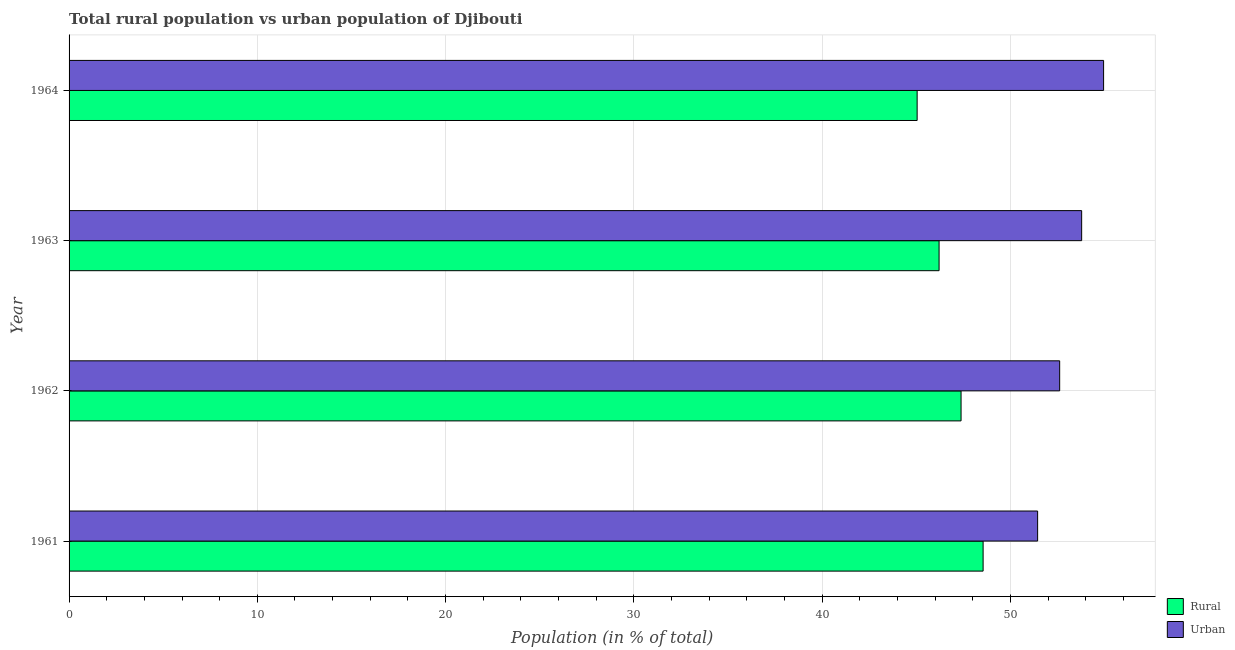How many different coloured bars are there?
Give a very brief answer. 2. Are the number of bars per tick equal to the number of legend labels?
Make the answer very short. Yes. How many bars are there on the 2nd tick from the bottom?
Your answer should be compact. 2. What is the label of the 1st group of bars from the top?
Give a very brief answer. 1964. In how many cases, is the number of bars for a given year not equal to the number of legend labels?
Your answer should be very brief. 0. What is the urban population in 1962?
Provide a short and direct response. 52.62. Across all years, what is the maximum urban population?
Offer a very short reply. 54.95. Across all years, what is the minimum urban population?
Provide a short and direct response. 51.45. In which year was the urban population maximum?
Your answer should be compact. 1964. In which year was the rural population minimum?
Offer a very short reply. 1964. What is the total rural population in the graph?
Keep it short and to the point. 187.19. What is the difference between the urban population in 1962 and that in 1964?
Your answer should be compact. -2.33. What is the difference between the urban population in 1964 and the rural population in 1963?
Keep it short and to the point. 8.74. What is the average rural population per year?
Offer a terse response. 46.8. In the year 1963, what is the difference between the rural population and urban population?
Offer a terse response. -7.57. What is the ratio of the urban population in 1962 to that in 1964?
Provide a short and direct response. 0.96. Is the rural population in 1961 less than that in 1964?
Your answer should be very brief. No. Is the difference between the rural population in 1961 and 1962 greater than the difference between the urban population in 1961 and 1962?
Your answer should be compact. Yes. What is the difference between the highest and the second highest urban population?
Give a very brief answer. 1.17. What is the difference between the highest and the lowest rural population?
Ensure brevity in your answer.  3.5. In how many years, is the urban population greater than the average urban population taken over all years?
Your answer should be very brief. 2. What does the 2nd bar from the top in 1961 represents?
Keep it short and to the point. Rural. What does the 1st bar from the bottom in 1962 represents?
Make the answer very short. Rural. Are all the bars in the graph horizontal?
Provide a short and direct response. Yes. Are the values on the major ticks of X-axis written in scientific E-notation?
Ensure brevity in your answer.  No. Does the graph contain grids?
Provide a succinct answer. Yes. Where does the legend appear in the graph?
Offer a very short reply. Bottom right. How many legend labels are there?
Offer a terse response. 2. How are the legend labels stacked?
Ensure brevity in your answer.  Vertical. What is the title of the graph?
Give a very brief answer. Total rural population vs urban population of Djibouti. Does "Official aid received" appear as one of the legend labels in the graph?
Keep it short and to the point. No. What is the label or title of the X-axis?
Offer a terse response. Population (in % of total). What is the label or title of the Y-axis?
Ensure brevity in your answer.  Year. What is the Population (in % of total) of Rural in 1961?
Provide a short and direct response. 48.55. What is the Population (in % of total) of Urban in 1961?
Your response must be concise. 51.45. What is the Population (in % of total) in Rural in 1962?
Provide a short and direct response. 47.38. What is the Population (in % of total) in Urban in 1962?
Offer a terse response. 52.62. What is the Population (in % of total) of Rural in 1963?
Provide a succinct answer. 46.21. What is the Population (in % of total) of Urban in 1963?
Offer a very short reply. 53.79. What is the Population (in % of total) in Rural in 1964?
Your answer should be very brief. 45.05. What is the Population (in % of total) in Urban in 1964?
Your response must be concise. 54.95. Across all years, what is the maximum Population (in % of total) in Rural?
Provide a short and direct response. 48.55. Across all years, what is the maximum Population (in % of total) of Urban?
Make the answer very short. 54.95. Across all years, what is the minimum Population (in % of total) of Rural?
Make the answer very short. 45.05. Across all years, what is the minimum Population (in % of total) of Urban?
Your response must be concise. 51.45. What is the total Population (in % of total) of Rural in the graph?
Make the answer very short. 187.19. What is the total Population (in % of total) of Urban in the graph?
Offer a terse response. 212.81. What is the difference between the Population (in % of total) of Rural in 1961 and that in 1962?
Provide a short and direct response. 1.17. What is the difference between the Population (in % of total) in Urban in 1961 and that in 1962?
Your answer should be very brief. -1.17. What is the difference between the Population (in % of total) of Rural in 1961 and that in 1963?
Offer a very short reply. 2.34. What is the difference between the Population (in % of total) in Urban in 1961 and that in 1963?
Make the answer very short. -2.34. What is the difference between the Population (in % of total) in Rural in 1961 and that in 1964?
Provide a succinct answer. 3.5. What is the difference between the Population (in % of total) in Urban in 1961 and that in 1964?
Keep it short and to the point. -3.5. What is the difference between the Population (in % of total) of Rural in 1962 and that in 1963?
Provide a short and direct response. 1.17. What is the difference between the Population (in % of total) of Urban in 1962 and that in 1963?
Offer a very short reply. -1.17. What is the difference between the Population (in % of total) in Rural in 1962 and that in 1964?
Give a very brief answer. 2.33. What is the difference between the Population (in % of total) of Urban in 1962 and that in 1964?
Provide a succinct answer. -2.33. What is the difference between the Population (in % of total) in Rural in 1963 and that in 1964?
Provide a succinct answer. 1.17. What is the difference between the Population (in % of total) in Urban in 1963 and that in 1964?
Ensure brevity in your answer.  -1.17. What is the difference between the Population (in % of total) in Rural in 1961 and the Population (in % of total) in Urban in 1962?
Make the answer very short. -4.07. What is the difference between the Population (in % of total) in Rural in 1961 and the Population (in % of total) in Urban in 1963?
Provide a succinct answer. -5.24. What is the difference between the Population (in % of total) of Rural in 1962 and the Population (in % of total) of Urban in 1963?
Give a very brief answer. -6.41. What is the difference between the Population (in % of total) in Rural in 1962 and the Population (in % of total) in Urban in 1964?
Your answer should be very brief. -7.57. What is the difference between the Population (in % of total) in Rural in 1963 and the Population (in % of total) in Urban in 1964?
Offer a terse response. -8.74. What is the average Population (in % of total) in Rural per year?
Your answer should be very brief. 46.8. What is the average Population (in % of total) of Urban per year?
Offer a very short reply. 53.2. In the year 1961, what is the difference between the Population (in % of total) of Rural and Population (in % of total) of Urban?
Provide a short and direct response. -2.9. In the year 1962, what is the difference between the Population (in % of total) of Rural and Population (in % of total) of Urban?
Ensure brevity in your answer.  -5.24. In the year 1963, what is the difference between the Population (in % of total) of Rural and Population (in % of total) of Urban?
Offer a terse response. -7.57. In the year 1964, what is the difference between the Population (in % of total) in Rural and Population (in % of total) in Urban?
Give a very brief answer. -9.9. What is the ratio of the Population (in % of total) in Rural in 1961 to that in 1962?
Keep it short and to the point. 1.02. What is the ratio of the Population (in % of total) of Urban in 1961 to that in 1962?
Offer a terse response. 0.98. What is the ratio of the Population (in % of total) of Rural in 1961 to that in 1963?
Your response must be concise. 1.05. What is the ratio of the Population (in % of total) of Urban in 1961 to that in 1963?
Provide a succinct answer. 0.96. What is the ratio of the Population (in % of total) in Rural in 1961 to that in 1964?
Your answer should be very brief. 1.08. What is the ratio of the Population (in % of total) of Urban in 1961 to that in 1964?
Ensure brevity in your answer.  0.94. What is the ratio of the Population (in % of total) in Rural in 1962 to that in 1963?
Give a very brief answer. 1.03. What is the ratio of the Population (in % of total) in Urban in 1962 to that in 1963?
Provide a succinct answer. 0.98. What is the ratio of the Population (in % of total) in Rural in 1962 to that in 1964?
Keep it short and to the point. 1.05. What is the ratio of the Population (in % of total) of Urban in 1962 to that in 1964?
Ensure brevity in your answer.  0.96. What is the ratio of the Population (in % of total) of Rural in 1963 to that in 1964?
Your answer should be compact. 1.03. What is the ratio of the Population (in % of total) of Urban in 1963 to that in 1964?
Your answer should be very brief. 0.98. What is the difference between the highest and the second highest Population (in % of total) in Rural?
Keep it short and to the point. 1.17. What is the difference between the highest and the second highest Population (in % of total) of Urban?
Provide a short and direct response. 1.17. What is the difference between the highest and the lowest Population (in % of total) of Rural?
Keep it short and to the point. 3.5. What is the difference between the highest and the lowest Population (in % of total) of Urban?
Your response must be concise. 3.5. 